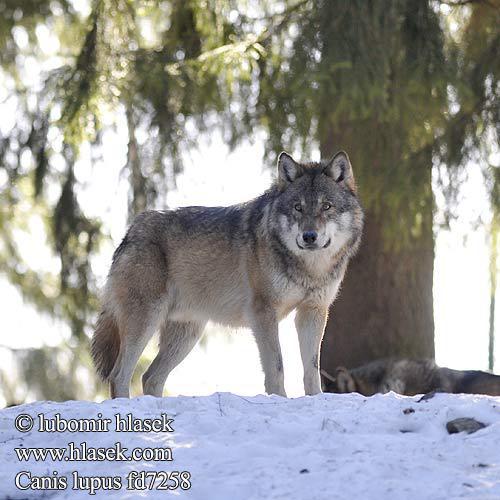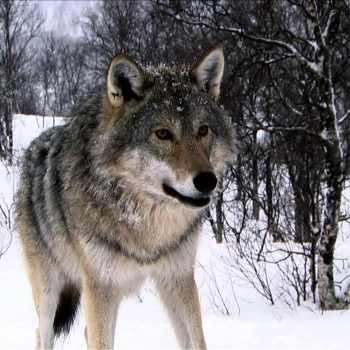The first image is the image on the left, the second image is the image on the right. Assess this claim about the two images: "The right image contains two or fewer wolves.". Correct or not? Answer yes or no. Yes. The first image is the image on the left, the second image is the image on the right. Given the left and right images, does the statement "An image features exactly three wolves, which look toward the camera." hold true? Answer yes or no. No. 